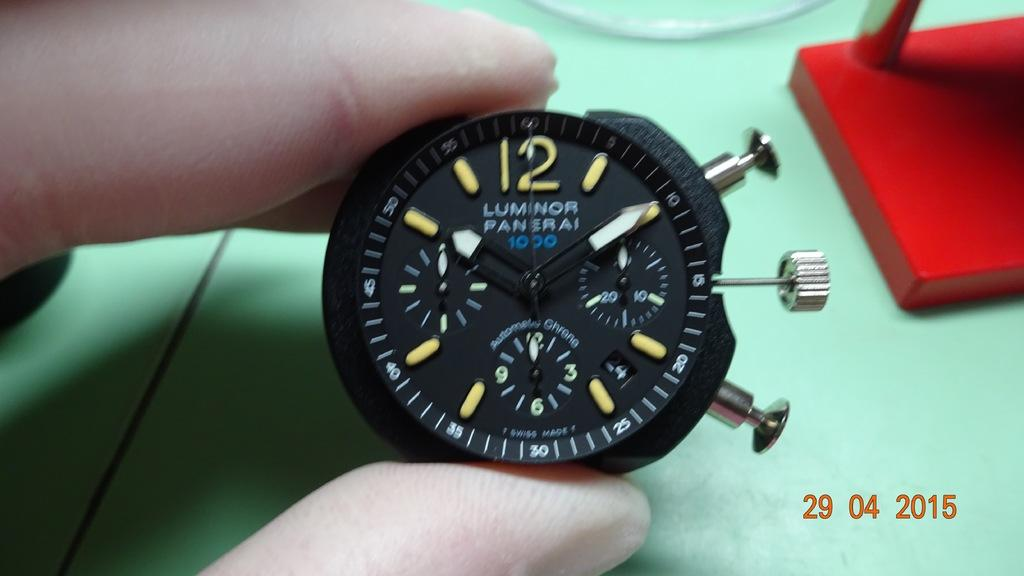<image>
Render a clear and concise summary of the photo. A person is holding a Luminor Panserai watch face. 